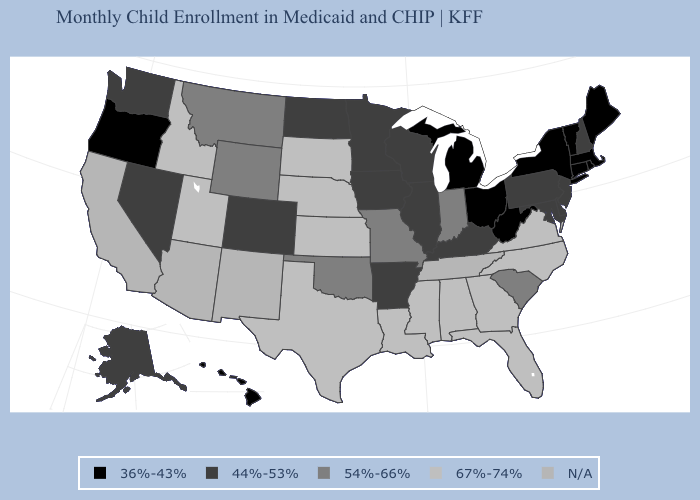Name the states that have a value in the range 36%-43%?
Answer briefly. Connecticut, Hawaii, Maine, Massachusetts, Michigan, New York, Ohio, Oregon, Rhode Island, Vermont, West Virginia. Among the states that border Arkansas , which have the highest value?
Give a very brief answer. Louisiana, Mississippi, Texas. What is the value of Michigan?
Answer briefly. 36%-43%. Is the legend a continuous bar?
Keep it brief. No. Name the states that have a value in the range 54%-66%?
Keep it brief. Indiana, Missouri, Montana, Oklahoma, South Carolina, Wyoming. What is the value of Kentucky?
Be succinct. 44%-53%. Does New Hampshire have the lowest value in the Northeast?
Keep it brief. No. Does Virginia have the highest value in the USA?
Concise answer only. Yes. How many symbols are there in the legend?
Quick response, please. 5. Is the legend a continuous bar?
Keep it brief. No. Name the states that have a value in the range 54%-66%?
Answer briefly. Indiana, Missouri, Montana, Oklahoma, South Carolina, Wyoming. What is the value of Wisconsin?
Be succinct. 44%-53%. Name the states that have a value in the range N/A?
Give a very brief answer. Arizona, California, New Mexico, Tennessee. What is the value of Georgia?
Write a very short answer. 67%-74%. Which states have the highest value in the USA?
Keep it brief. Alabama, Florida, Georgia, Idaho, Kansas, Louisiana, Mississippi, Nebraska, North Carolina, South Dakota, Texas, Utah, Virginia. 